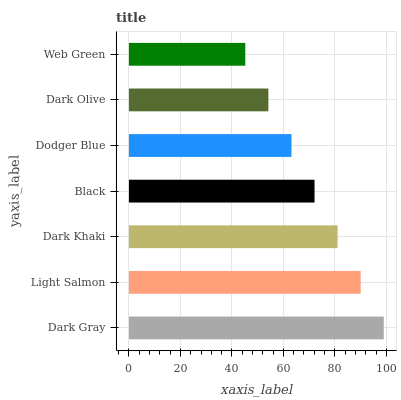Is Web Green the minimum?
Answer yes or no. Yes. Is Dark Gray the maximum?
Answer yes or no. Yes. Is Light Salmon the minimum?
Answer yes or no. No. Is Light Salmon the maximum?
Answer yes or no. No. Is Dark Gray greater than Light Salmon?
Answer yes or no. Yes. Is Light Salmon less than Dark Gray?
Answer yes or no. Yes. Is Light Salmon greater than Dark Gray?
Answer yes or no. No. Is Dark Gray less than Light Salmon?
Answer yes or no. No. Is Black the high median?
Answer yes or no. Yes. Is Black the low median?
Answer yes or no. Yes. Is Dodger Blue the high median?
Answer yes or no. No. Is Dark Khaki the low median?
Answer yes or no. No. 